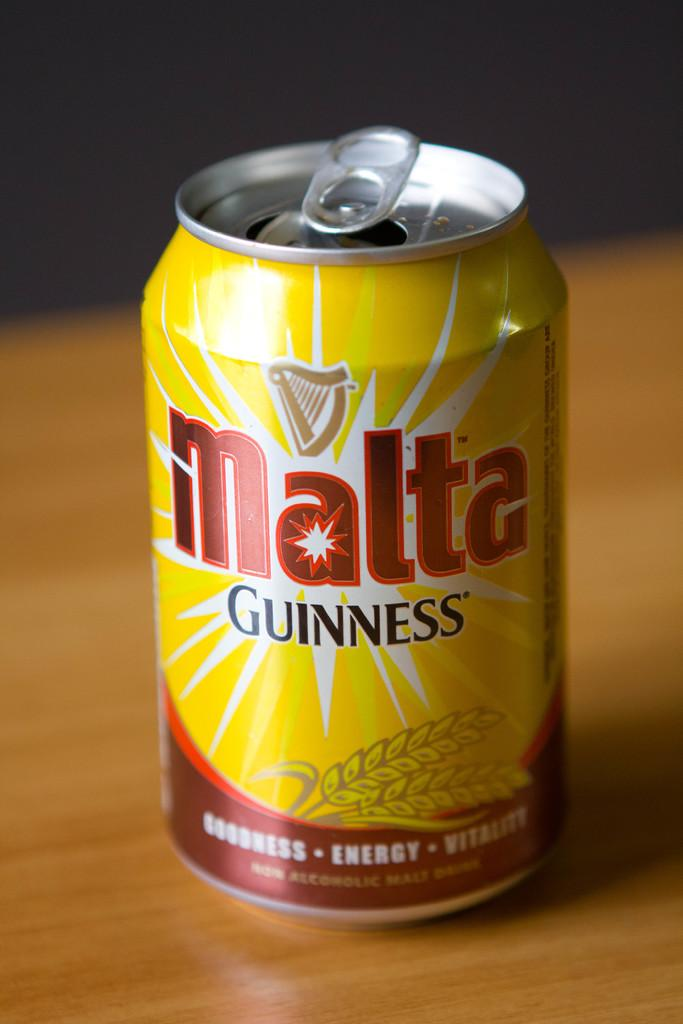<image>
Create a compact narrative representing the image presented. the word malta is on the red and yellow can 